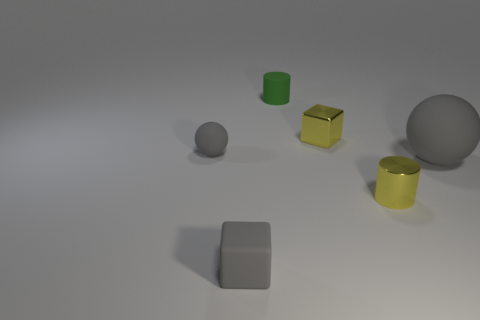Add 2 purple shiny objects. How many objects exist? 8 Subtract 1 cylinders. How many cylinders are left? 1 Subtract all blocks. How many objects are left? 4 Subtract all gray cubes. How many cubes are left? 1 Subtract 0 blue cylinders. How many objects are left? 6 Subtract all green cylinders. Subtract all red blocks. How many cylinders are left? 1 Subtract all blue balls. How many gray cubes are left? 1 Subtract all big spheres. Subtract all cubes. How many objects are left? 3 Add 3 green objects. How many green objects are left? 4 Add 2 tiny shiny things. How many tiny shiny things exist? 4 